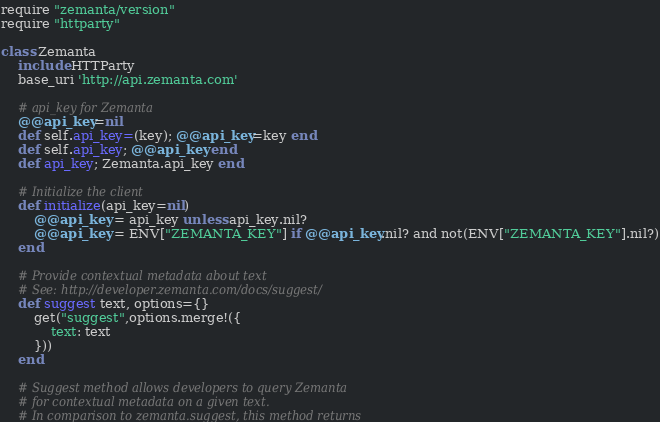Convert code to text. <code><loc_0><loc_0><loc_500><loc_500><_Ruby_>require "zemanta/version"
require "httparty"

class Zemanta
	include HTTParty
	base_uri 'http://api.zemanta.com'

	# api_key for Zemanta
	@@api_key=nil
	def self.api_key=(key); @@api_key=key end
	def self.api_key; @@api_key end
	def api_key; Zemanta.api_key end

	# Initialize the client
	def initialize(api_key=nil)
		@@api_key = api_key unless api_key.nil?
		@@api_key = ENV["ZEMANTA_KEY"] if @@api_key.nil? and not(ENV["ZEMANTA_KEY"].nil?)
	end

	# Provide contextual metadata about text
	# See: http://developer.zemanta.com/docs/suggest/
	def suggest text, options={}
		get("suggest",options.merge!({
			text: text
		}))
	end

	# Suggest method allows developers to query Zemanta
	# for contextual metadata on a given text.
	# In comparison to zemanta.suggest, this method returns</code> 